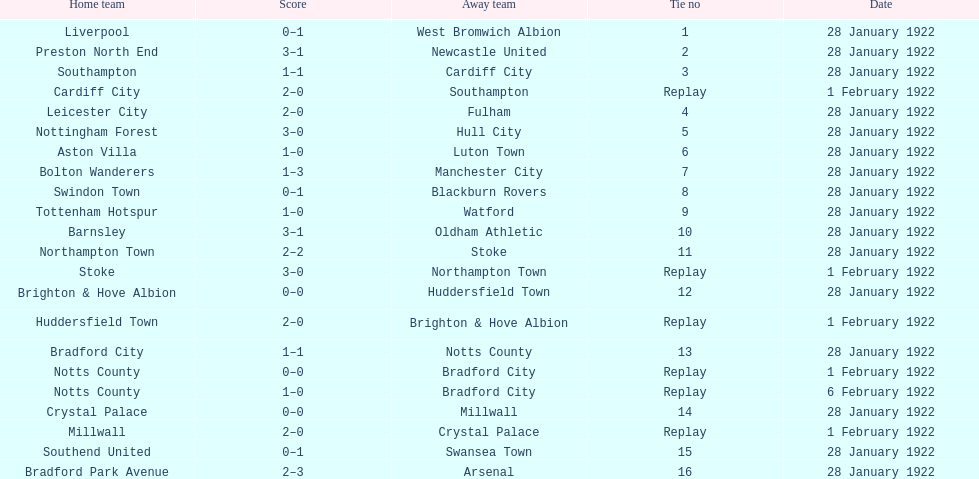How many games had four total points scored or more? 5. 